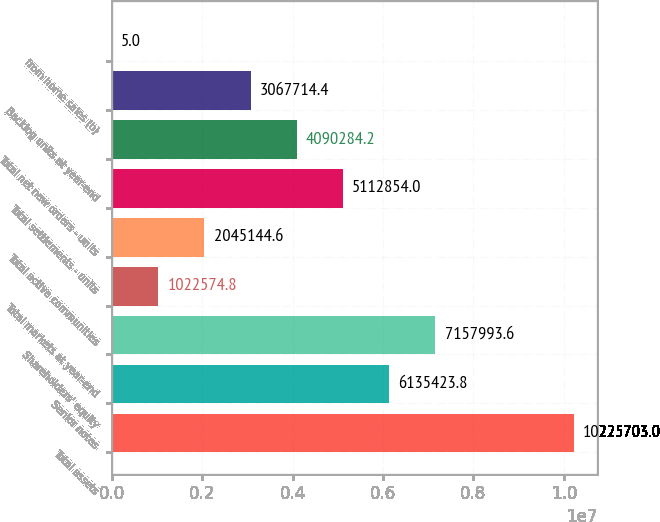Convert chart to OTSL. <chart><loc_0><loc_0><loc_500><loc_500><bar_chart><fcel>Total assets<fcel>Senior notes<fcel>Shareholders' equity<fcel>Total markets at year-end<fcel>Total active communities<fcel>Total settlements - units<fcel>Total net new orders - units<fcel>Backlog units at year-end<fcel>from home sales (b)<nl><fcel>1.02257e+07<fcel>6.13542e+06<fcel>7.15799e+06<fcel>1.02257e+06<fcel>2.04514e+06<fcel>5.11285e+06<fcel>4.09028e+06<fcel>3.06771e+06<fcel>5<nl></chart> 